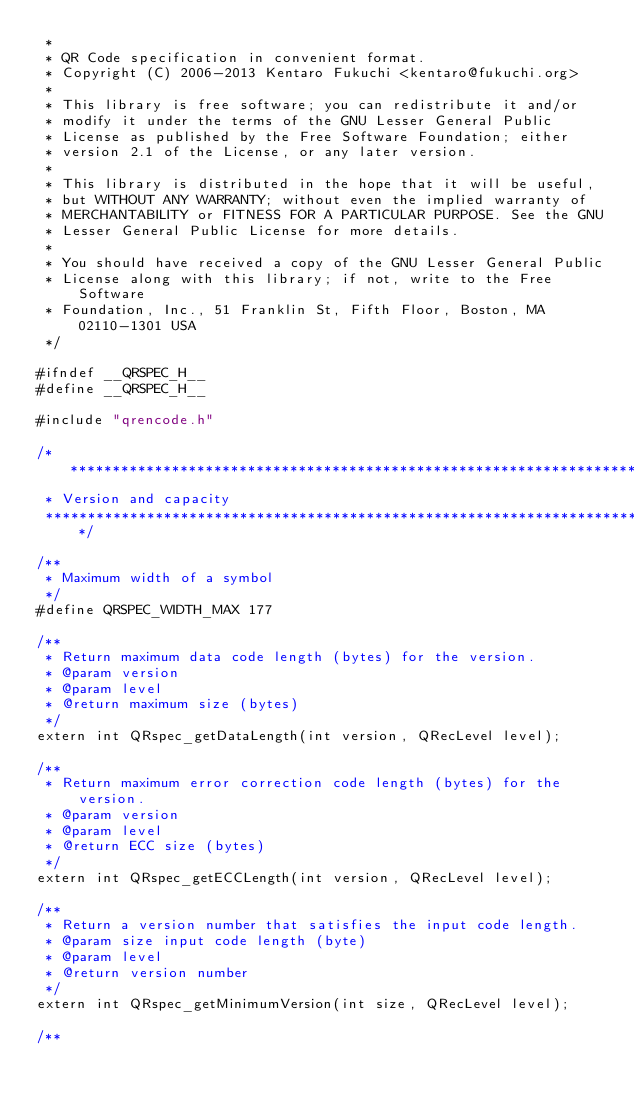Convert code to text. <code><loc_0><loc_0><loc_500><loc_500><_C_> *
 * QR Code specification in convenient format. 
 * Copyright (C) 2006-2013 Kentaro Fukuchi <kentaro@fukuchi.org>
 *
 * This library is free software; you can redistribute it and/or
 * modify it under the terms of the GNU Lesser General Public
 * License as published by the Free Software Foundation; either
 * version 2.1 of the License, or any later version.
 *
 * This library is distributed in the hope that it will be useful,
 * but WITHOUT ANY WARRANTY; without even the implied warranty of
 * MERCHANTABILITY or FITNESS FOR A PARTICULAR PURPOSE. See the GNU
 * Lesser General Public License for more details.
 *
 * You should have received a copy of the GNU Lesser General Public
 * License along with this library; if not, write to the Free Software
 * Foundation, Inc., 51 Franklin St, Fifth Floor, Boston, MA 02110-1301 USA
 */

#ifndef __QRSPEC_H__
#define __QRSPEC_H__

#include "qrencode.h"

/******************************************************************************
 * Version and capacity
 *****************************************************************************/

/**
 * Maximum width of a symbol
 */
#define QRSPEC_WIDTH_MAX 177

/**
 * Return maximum data code length (bytes) for the version.
 * @param version
 * @param level
 * @return maximum size (bytes)
 */
extern int QRspec_getDataLength(int version, QRecLevel level);

/**
 * Return maximum error correction code length (bytes) for the version.
 * @param version
 * @param level
 * @return ECC size (bytes)
 */
extern int QRspec_getECCLength(int version, QRecLevel level);

/**
 * Return a version number that satisfies the input code length.
 * @param size input code length (byte)
 * @param level
 * @return version number
 */
extern int QRspec_getMinimumVersion(int size, QRecLevel level);

/**</code> 